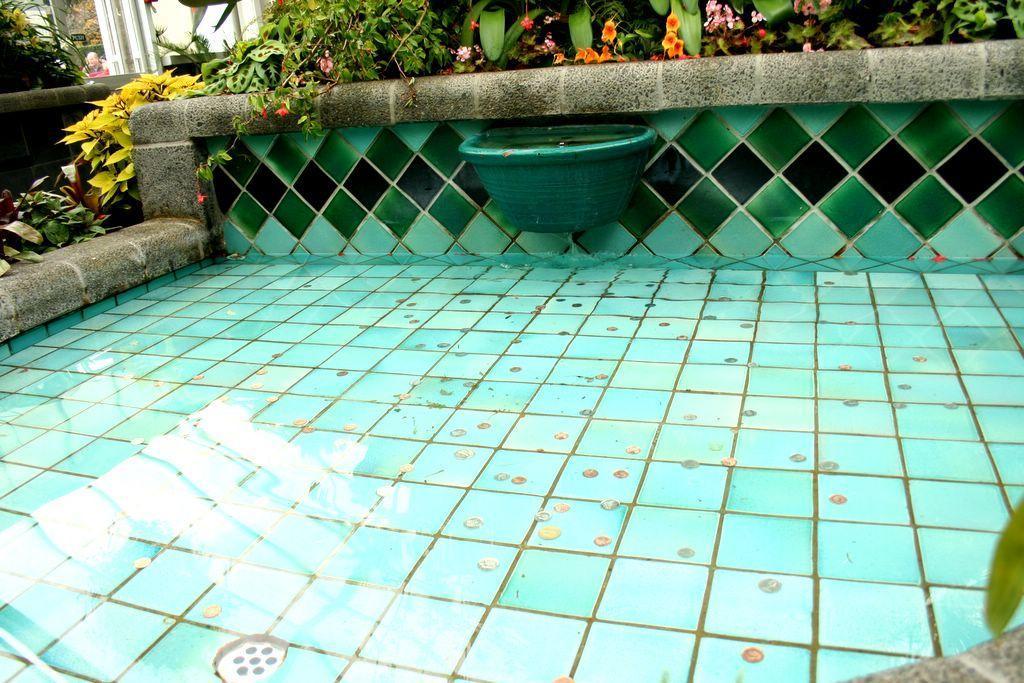Describe this image in one or two sentences. In this image, we can see some water. We can also see the wall and some plants. We can see a person. We can also see an object attached to the wall. We can see some white colored objects. 